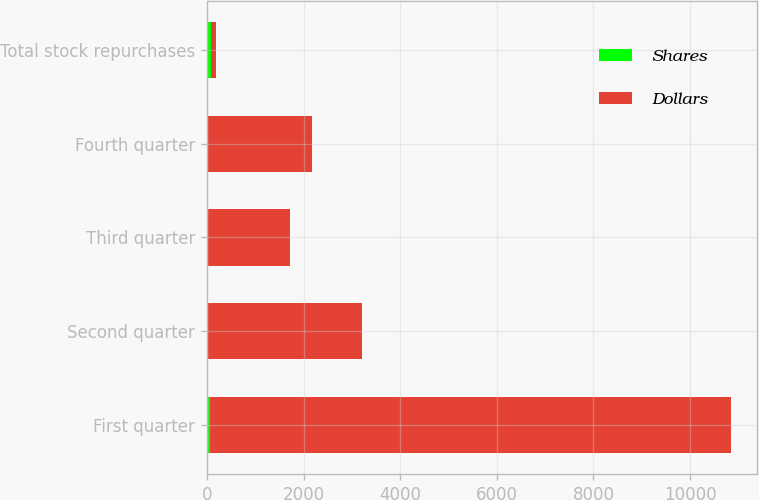Convert chart. <chart><loc_0><loc_0><loc_500><loc_500><stacked_bar_chart><ecel><fcel>First quarter<fcel>Second quarter<fcel>Third quarter<fcel>Fourth quarter<fcel>Total stock repurchases<nl><fcel>Shares<fcel>56.4<fcel>18.2<fcel>8.7<fcel>11.1<fcel>94.5<nl><fcel>Dollars<fcel>10787<fcel>3190<fcel>1713<fcel>2165<fcel>94.5<nl></chart> 